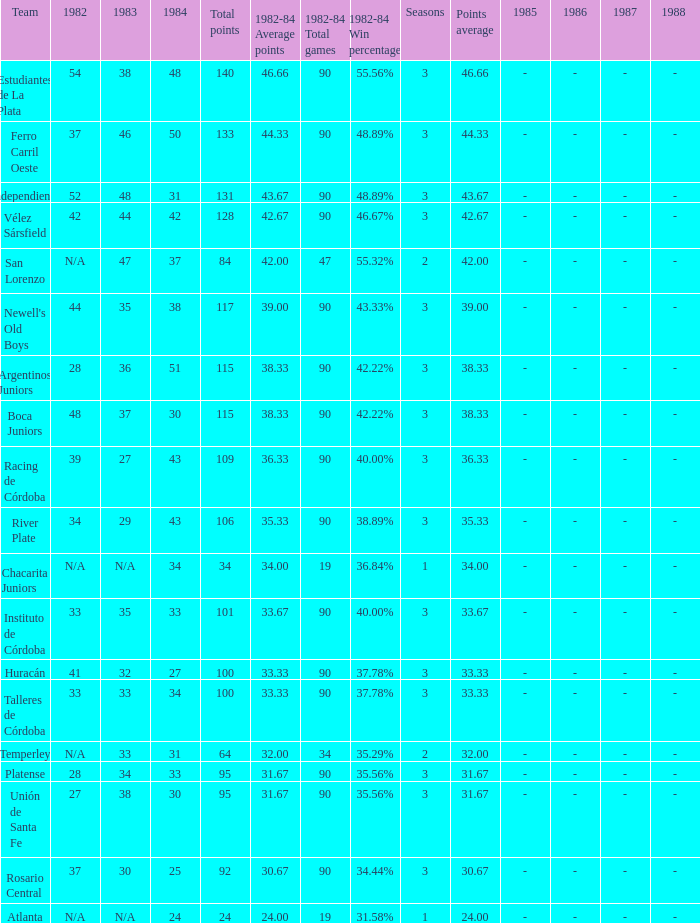What is the total for 1984 for the team with 100 points total and more than 3 seasons? None. 